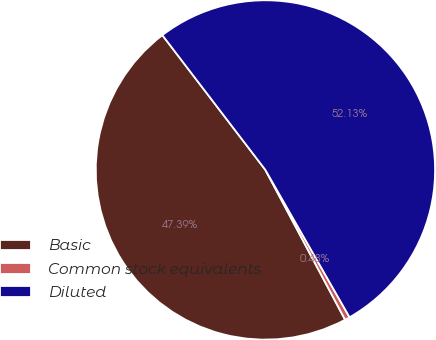Convert chart. <chart><loc_0><loc_0><loc_500><loc_500><pie_chart><fcel>Basic<fcel>Common stock equivalents<fcel>Diluted<nl><fcel>47.39%<fcel>0.48%<fcel>52.13%<nl></chart> 